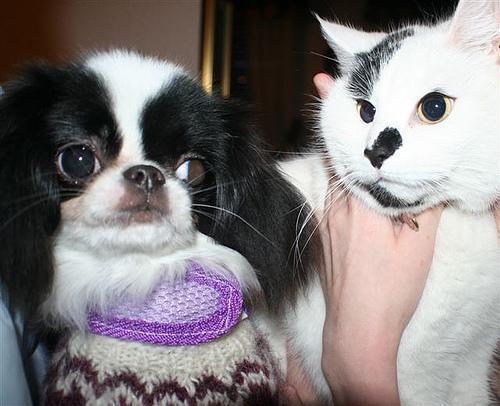How many animals in the pic?
Give a very brief answer. 2. How many animals in this picture?
Give a very brief answer. 2. How many dogs in this picture?
Give a very brief answer. 1. How many pets are here?
Give a very brief answer. 2. How many fingers of the hand can be seen sticking up?
Give a very brief answer. 1. How many dogs are visible?
Give a very brief answer. 1. How many motorcycles in the picture?
Give a very brief answer. 0. 